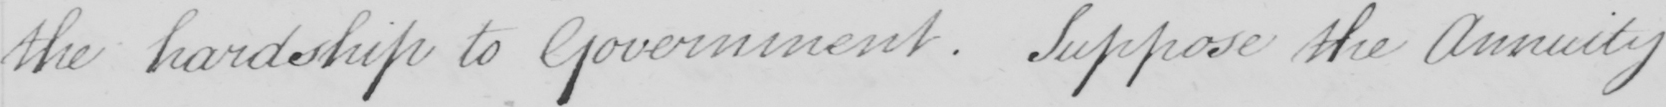What is written in this line of handwriting? the hardship to Government . Suppose the Annuity 